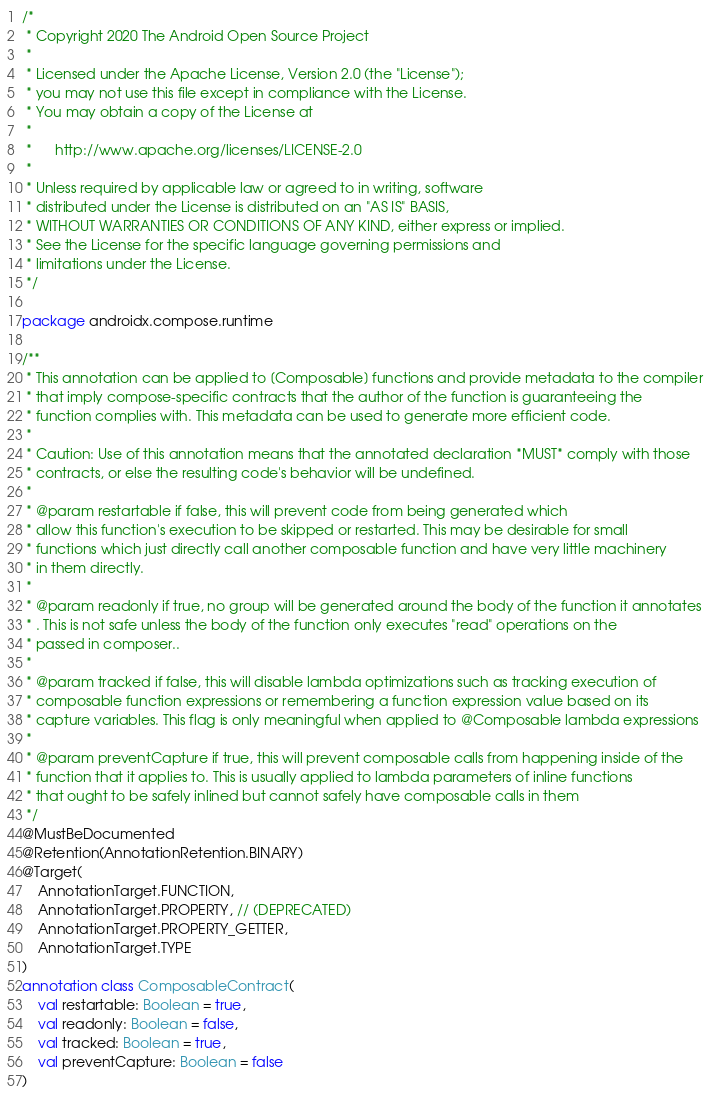Convert code to text. <code><loc_0><loc_0><loc_500><loc_500><_Kotlin_>/*
 * Copyright 2020 The Android Open Source Project
 *
 * Licensed under the Apache License, Version 2.0 (the "License");
 * you may not use this file except in compliance with the License.
 * You may obtain a copy of the License at
 *
 *      http://www.apache.org/licenses/LICENSE-2.0
 *
 * Unless required by applicable law or agreed to in writing, software
 * distributed under the License is distributed on an "AS IS" BASIS,
 * WITHOUT WARRANTIES OR CONDITIONS OF ANY KIND, either express or implied.
 * See the License for the specific language governing permissions and
 * limitations under the License.
 */

package androidx.compose.runtime

/**
 * This annotation can be applied to [Composable] functions and provide metadata to the compiler
 * that imply compose-specific contracts that the author of the function is guaranteeing the
 * function complies with. This metadata can be used to generate more efficient code.
 *
 * Caution: Use of this annotation means that the annotated declaration *MUST* comply with those
 * contracts, or else the resulting code's behavior will be undefined.
 *
 * @param restartable if false, this will prevent code from being generated which
 * allow this function's execution to be skipped or restarted. This may be desirable for small
 * functions which just directly call another composable function and have very little machinery
 * in them directly.
 *
 * @param readonly if true, no group will be generated around the body of the function it annotates
 * . This is not safe unless the body of the function only executes "read" operations on the
 * passed in composer..
 *
 * @param tracked if false, this will disable lambda optimizations such as tracking execution of
 * composable function expressions or remembering a function expression value based on its
 * capture variables. This flag is only meaningful when applied to @Composable lambda expressions
 *
 * @param preventCapture if true, this will prevent composable calls from happening inside of the
 * function that it applies to. This is usually applied to lambda parameters of inline functions
 * that ought to be safely inlined but cannot safely have composable calls in them
 */
@MustBeDocumented
@Retention(AnnotationRetention.BINARY)
@Target(
    AnnotationTarget.FUNCTION,
    AnnotationTarget.PROPERTY, // (DEPRECATED)
    AnnotationTarget.PROPERTY_GETTER,
    AnnotationTarget.TYPE
)
annotation class ComposableContract(
    val restartable: Boolean = true,
    val readonly: Boolean = false,
    val tracked: Boolean = true,
    val preventCapture: Boolean = false
)</code> 